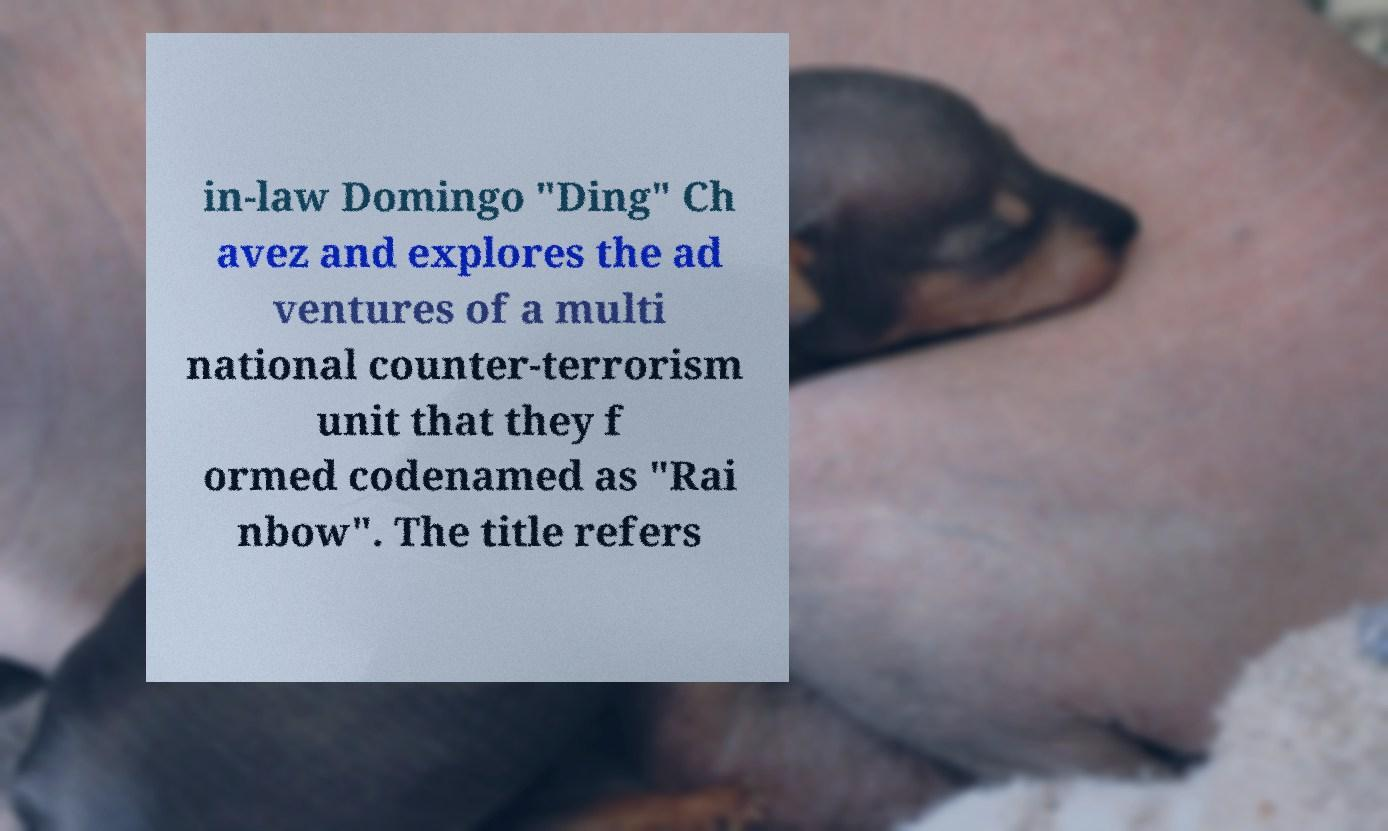Can you accurately transcribe the text from the provided image for me? in-law Domingo "Ding" Ch avez and explores the ad ventures of a multi national counter-terrorism unit that they f ormed codenamed as "Rai nbow". The title refers 